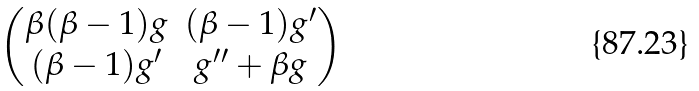<formula> <loc_0><loc_0><loc_500><loc_500>\begin{pmatrix} \beta ( \beta - 1 ) g & ( \beta - 1 ) g ^ { \prime } \\ ( \beta - 1 ) g ^ { \prime } & g ^ { \prime \prime } + \beta g \end{pmatrix}</formula> 